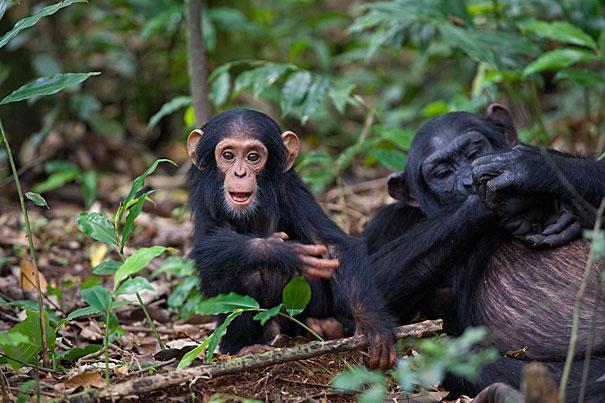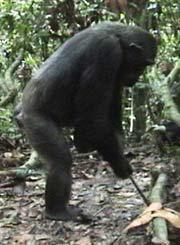The first image is the image on the left, the second image is the image on the right. Given the left and right images, does the statement "There are more animals in the image on the left." hold true? Answer yes or no. Yes. The first image is the image on the left, the second image is the image on the right. Given the left and right images, does the statement "One image shows a close-mouthed chimp holding a stick and poking it down at something." hold true? Answer yes or no. Yes. 